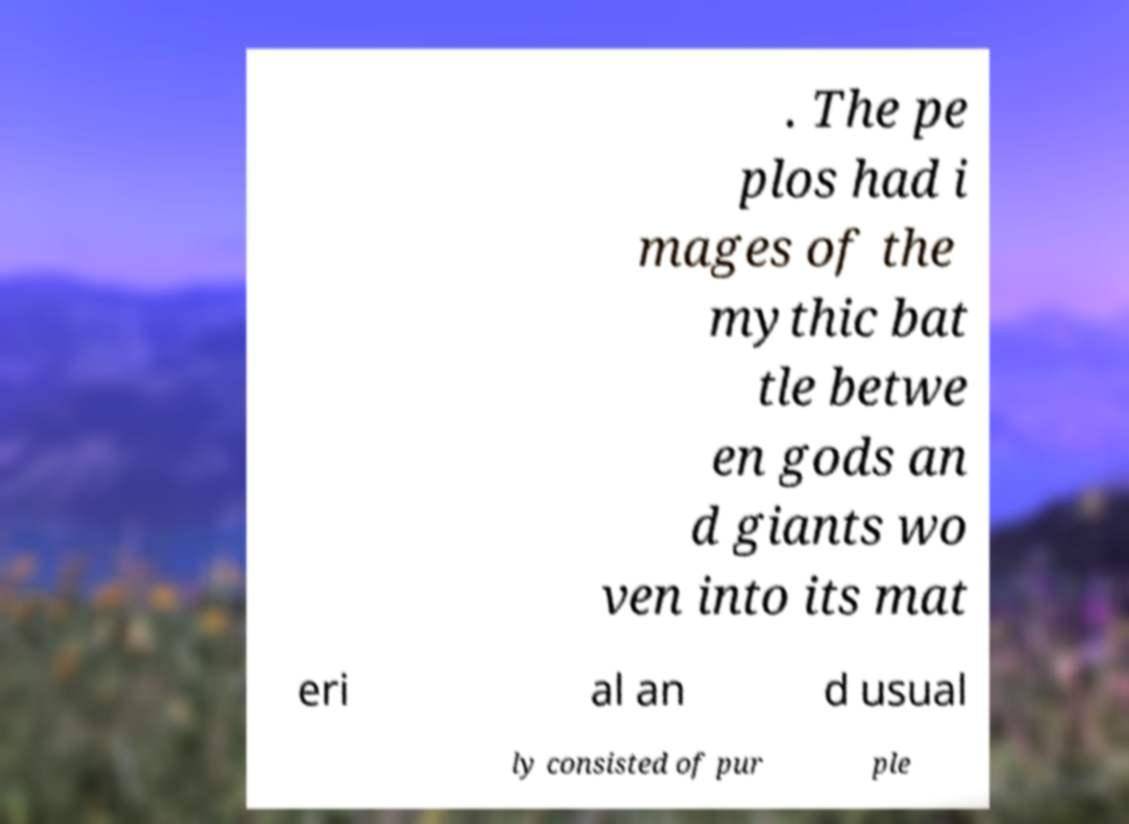Please identify and transcribe the text found in this image. . The pe plos had i mages of the mythic bat tle betwe en gods an d giants wo ven into its mat eri al an d usual ly consisted of pur ple 